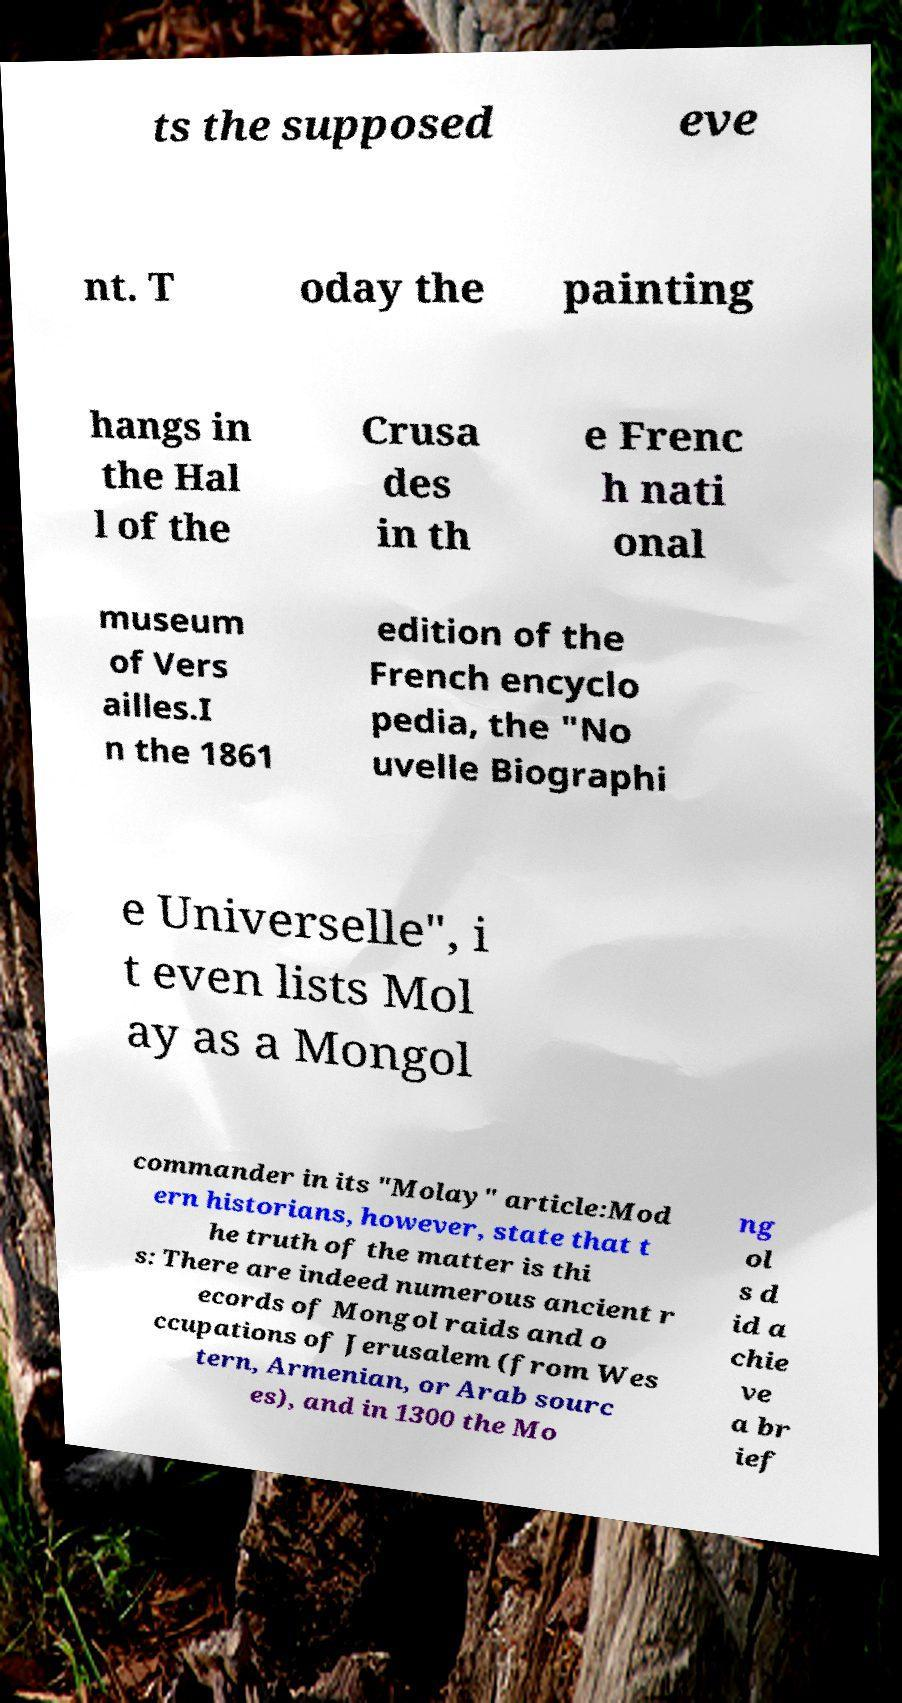What messages or text are displayed in this image? I need them in a readable, typed format. ts the supposed eve nt. T oday the painting hangs in the Hal l of the Crusa des in th e Frenc h nati onal museum of Vers ailles.I n the 1861 edition of the French encyclo pedia, the "No uvelle Biographi e Universelle", i t even lists Mol ay as a Mongol commander in its "Molay" article:Mod ern historians, however, state that t he truth of the matter is thi s: There are indeed numerous ancient r ecords of Mongol raids and o ccupations of Jerusalem (from Wes tern, Armenian, or Arab sourc es), and in 1300 the Mo ng ol s d id a chie ve a br ief 